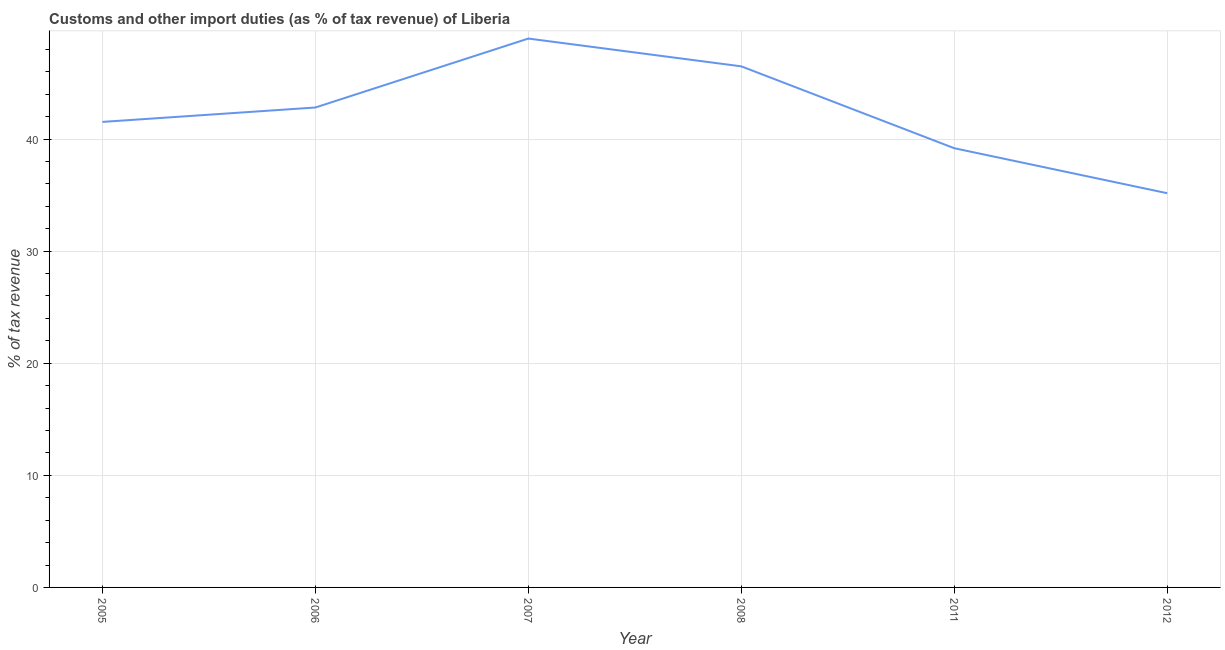What is the customs and other import duties in 2011?
Your answer should be compact. 39.18. Across all years, what is the maximum customs and other import duties?
Ensure brevity in your answer.  48.96. Across all years, what is the minimum customs and other import duties?
Your answer should be very brief. 35.17. In which year was the customs and other import duties maximum?
Keep it short and to the point. 2007. In which year was the customs and other import duties minimum?
Your response must be concise. 2012. What is the sum of the customs and other import duties?
Offer a terse response. 254.14. What is the difference between the customs and other import duties in 2008 and 2011?
Ensure brevity in your answer.  7.3. What is the average customs and other import duties per year?
Ensure brevity in your answer.  42.36. What is the median customs and other import duties?
Provide a succinct answer. 42.17. In how many years, is the customs and other import duties greater than 38 %?
Offer a very short reply. 5. What is the ratio of the customs and other import duties in 2006 to that in 2007?
Provide a short and direct response. 0.87. What is the difference between the highest and the second highest customs and other import duties?
Your answer should be compact. 2.48. What is the difference between the highest and the lowest customs and other import duties?
Give a very brief answer. 13.8. Does the customs and other import duties monotonically increase over the years?
Make the answer very short. No. How many lines are there?
Make the answer very short. 1. What is the title of the graph?
Keep it short and to the point. Customs and other import duties (as % of tax revenue) of Liberia. What is the label or title of the X-axis?
Provide a short and direct response. Year. What is the label or title of the Y-axis?
Keep it short and to the point. % of tax revenue. What is the % of tax revenue in 2005?
Your answer should be very brief. 41.53. What is the % of tax revenue of 2006?
Offer a very short reply. 42.81. What is the % of tax revenue of 2007?
Ensure brevity in your answer.  48.96. What is the % of tax revenue in 2008?
Offer a terse response. 46.48. What is the % of tax revenue of 2011?
Keep it short and to the point. 39.18. What is the % of tax revenue in 2012?
Give a very brief answer. 35.17. What is the difference between the % of tax revenue in 2005 and 2006?
Provide a succinct answer. -1.28. What is the difference between the % of tax revenue in 2005 and 2007?
Ensure brevity in your answer.  -7.44. What is the difference between the % of tax revenue in 2005 and 2008?
Your answer should be very brief. -4.96. What is the difference between the % of tax revenue in 2005 and 2011?
Give a very brief answer. 2.35. What is the difference between the % of tax revenue in 2005 and 2012?
Your answer should be very brief. 6.36. What is the difference between the % of tax revenue in 2006 and 2007?
Offer a terse response. -6.15. What is the difference between the % of tax revenue in 2006 and 2008?
Offer a very short reply. -3.67. What is the difference between the % of tax revenue in 2006 and 2011?
Your answer should be compact. 3.63. What is the difference between the % of tax revenue in 2006 and 2012?
Provide a succinct answer. 7.65. What is the difference between the % of tax revenue in 2007 and 2008?
Ensure brevity in your answer.  2.48. What is the difference between the % of tax revenue in 2007 and 2011?
Keep it short and to the point. 9.78. What is the difference between the % of tax revenue in 2007 and 2012?
Your response must be concise. 13.8. What is the difference between the % of tax revenue in 2008 and 2011?
Provide a short and direct response. 7.3. What is the difference between the % of tax revenue in 2008 and 2012?
Your answer should be very brief. 11.32. What is the difference between the % of tax revenue in 2011 and 2012?
Your answer should be compact. 4.01. What is the ratio of the % of tax revenue in 2005 to that in 2006?
Give a very brief answer. 0.97. What is the ratio of the % of tax revenue in 2005 to that in 2007?
Offer a very short reply. 0.85. What is the ratio of the % of tax revenue in 2005 to that in 2008?
Provide a succinct answer. 0.89. What is the ratio of the % of tax revenue in 2005 to that in 2011?
Your answer should be compact. 1.06. What is the ratio of the % of tax revenue in 2005 to that in 2012?
Your response must be concise. 1.18. What is the ratio of the % of tax revenue in 2006 to that in 2007?
Ensure brevity in your answer.  0.87. What is the ratio of the % of tax revenue in 2006 to that in 2008?
Provide a succinct answer. 0.92. What is the ratio of the % of tax revenue in 2006 to that in 2011?
Provide a short and direct response. 1.09. What is the ratio of the % of tax revenue in 2006 to that in 2012?
Your answer should be very brief. 1.22. What is the ratio of the % of tax revenue in 2007 to that in 2008?
Your response must be concise. 1.05. What is the ratio of the % of tax revenue in 2007 to that in 2011?
Give a very brief answer. 1.25. What is the ratio of the % of tax revenue in 2007 to that in 2012?
Offer a very short reply. 1.39. What is the ratio of the % of tax revenue in 2008 to that in 2011?
Give a very brief answer. 1.19. What is the ratio of the % of tax revenue in 2008 to that in 2012?
Your response must be concise. 1.32. What is the ratio of the % of tax revenue in 2011 to that in 2012?
Your answer should be compact. 1.11. 